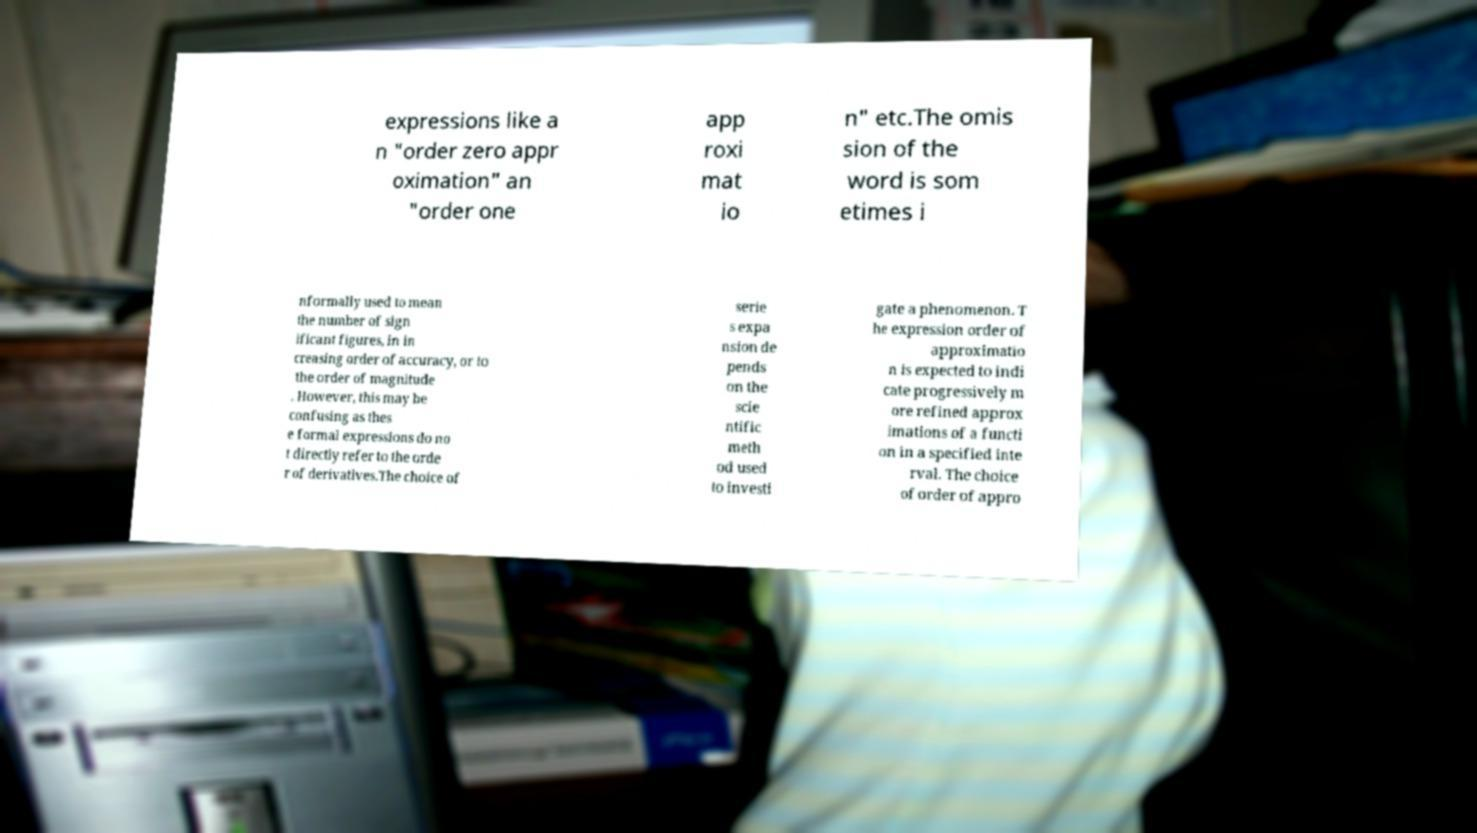Can you accurately transcribe the text from the provided image for me? expressions like a n "order zero appr oximation" an "order one app roxi mat io n" etc.The omis sion of the word is som etimes i nformally used to mean the number of sign ificant figures, in in creasing order of accuracy, or to the order of magnitude . However, this may be confusing as thes e formal expressions do no t directly refer to the orde r of derivatives.The choice of serie s expa nsion de pends on the scie ntific meth od used to investi gate a phenomenon. T he expression order of approximatio n is expected to indi cate progressively m ore refined approx imations of a functi on in a specified inte rval. The choice of order of appro 